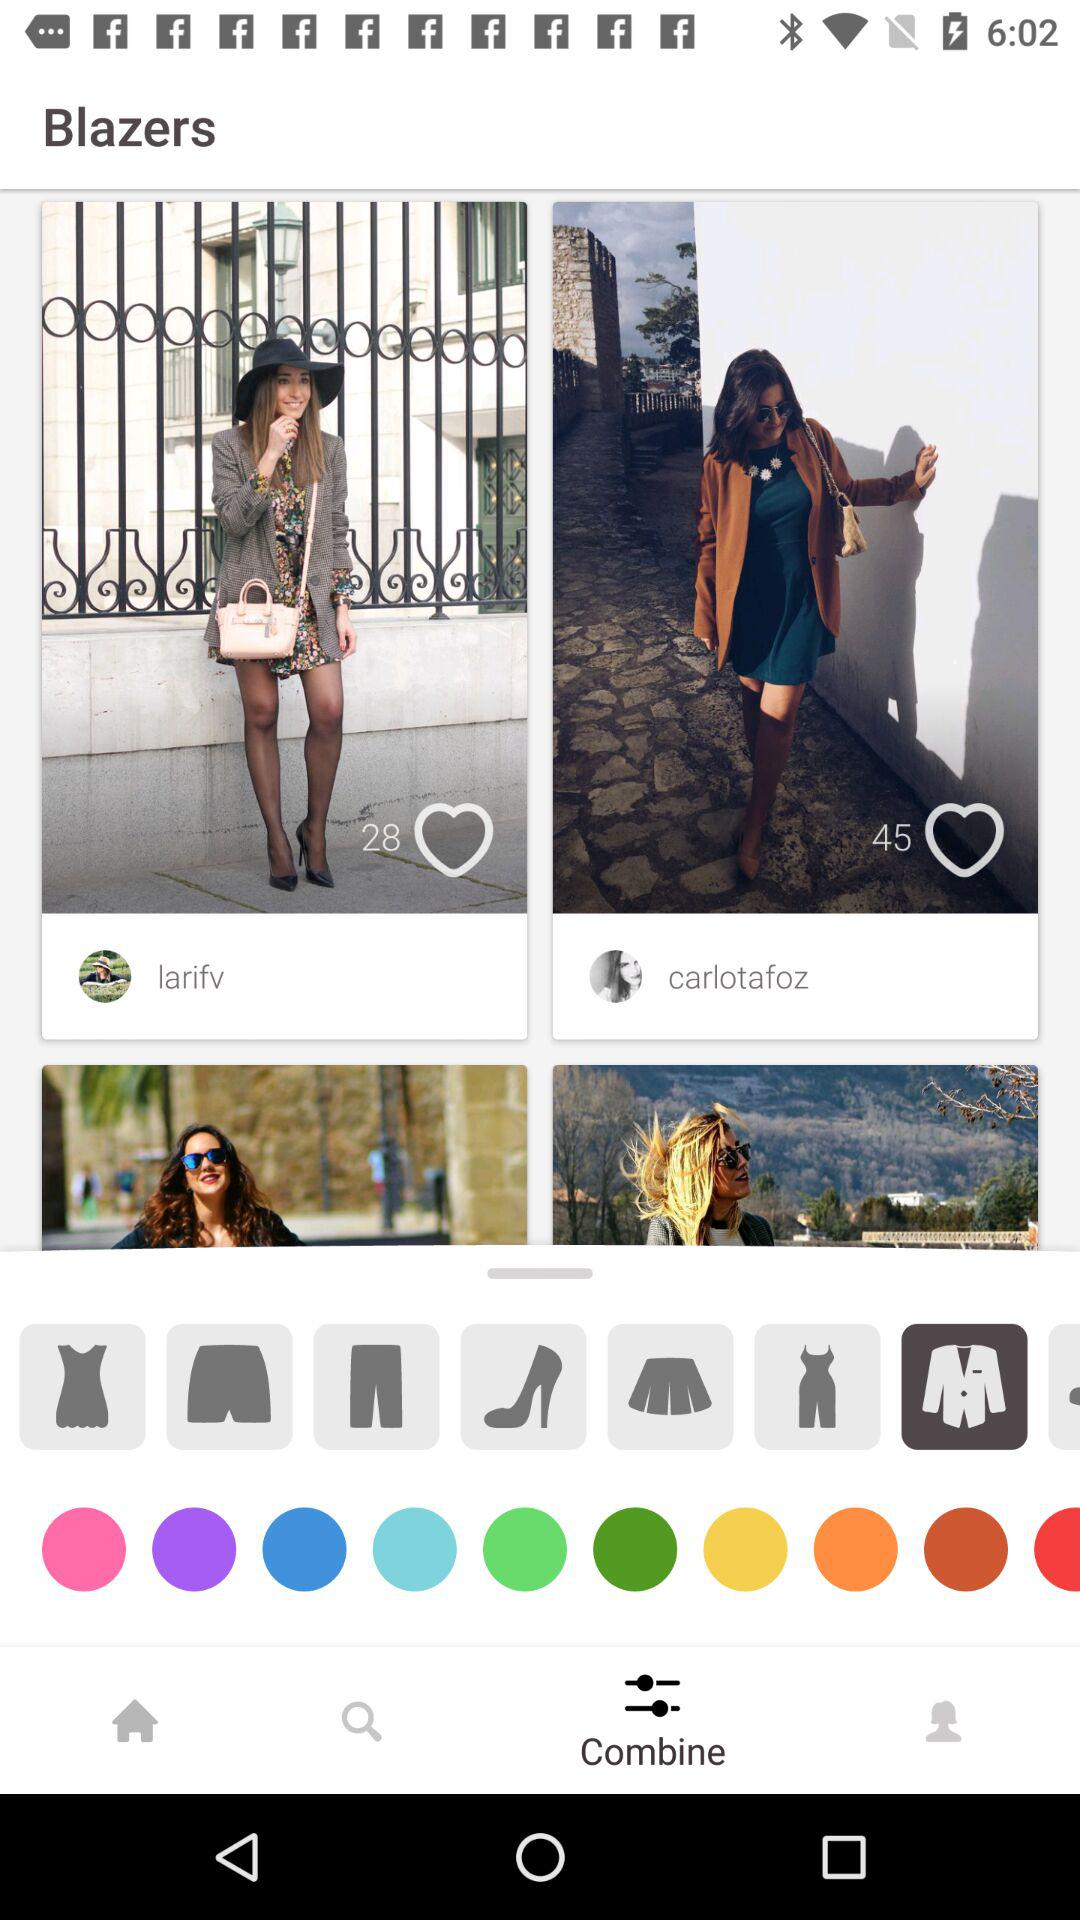Which tab is selected? The tab "Combine" is selected. 